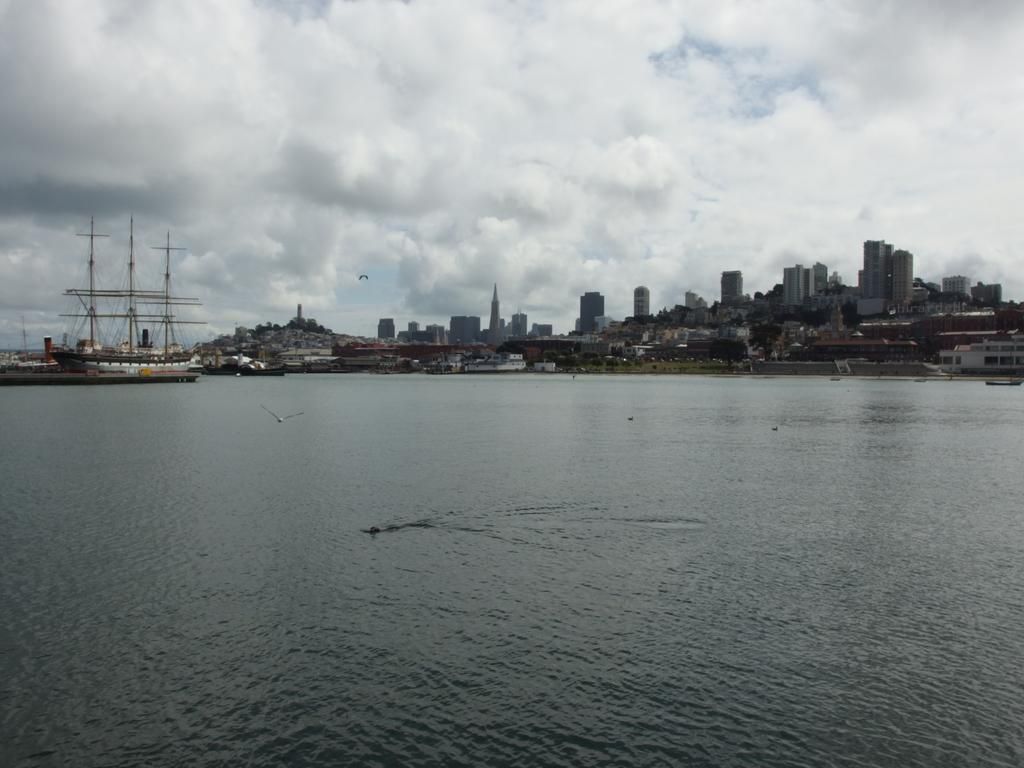What is the main subject of the image? The main subject of the image is multiple ships on the water surface. Can you describe the setting of the image? The ships are on the water surface, and there are buildings visible in the image. What is the condition of the sky in the image? The sky is cloudy in the image. What type of bears can be seen fearing the burst of water in the image? There are no bears or bursts of water present in the image. 